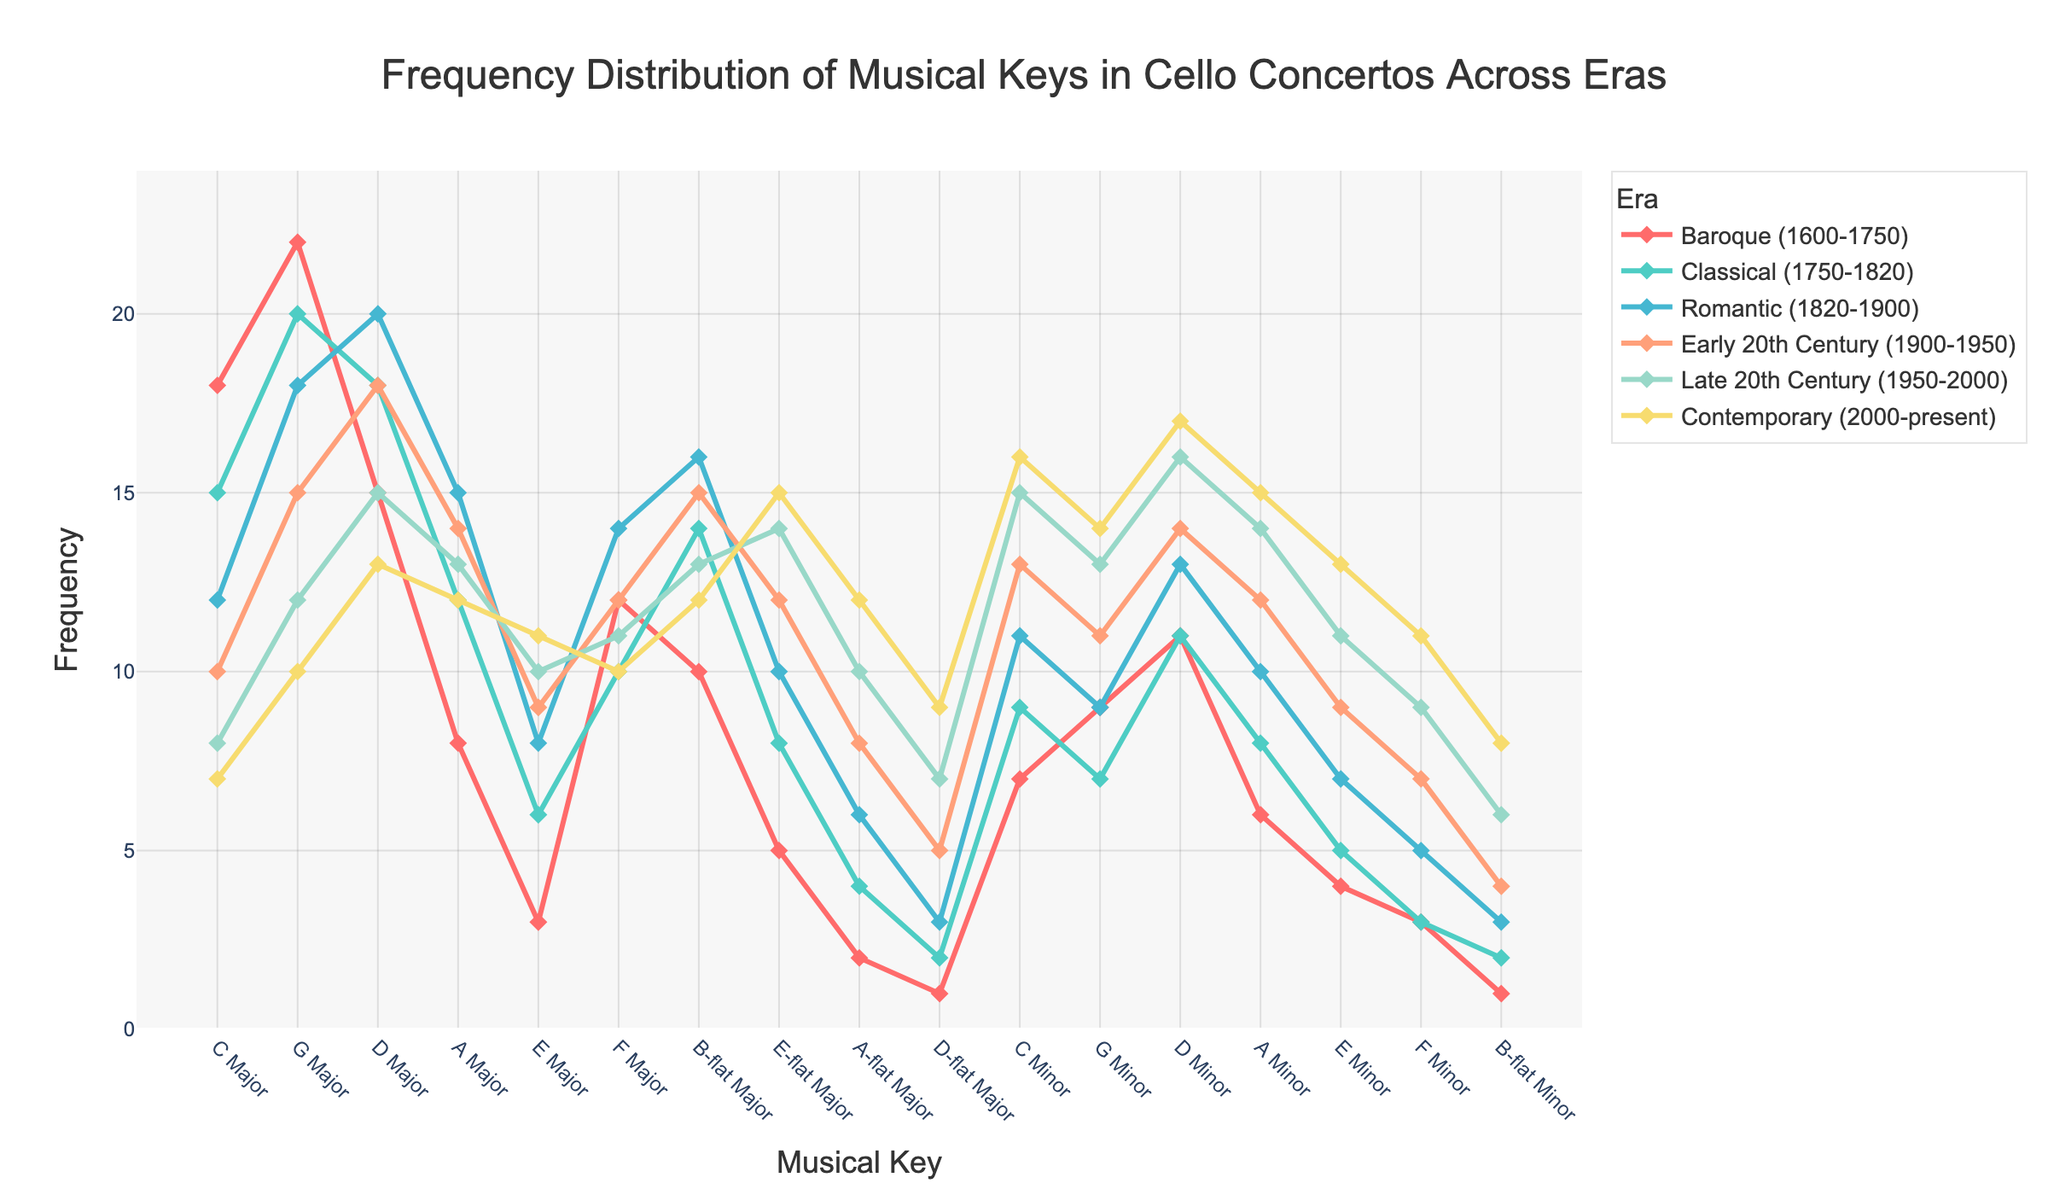Which era has the highest frequency of concertos in C Major? Look for the era with the tallest line at the point corresponding to C Major. In this case, it's the "Baroque (1600-1750)" era with a frequency of 18.
Answer: Baroque (1600-1750) How does the frequency of D Minor concertos change from the Classical to the Contemporary era? Observe the frequency of D Minor in the Classical and Contemporary eras. In the Classical era, it is 11. In the Contemporary era, it is 17. Subtract the former from the latter to find the change.
Answer: Increased by 6 Which musical key shows the most significant increase from the Baroque era to the Contemporary era? Compare the frequencies of each musical key in both eras, looking for the key with the maximum increase. D Minor goes from 11 in Baroque to 17 in Contemporary, with an increase of 6.
Answer: D Minor What's the average frequency of concertos in G Major across all eras? Sum the frequencies of G Major across all eras (22 + 20 + 18 + 15 + 12 + 10 = 97). Divide by the number of eras (6).
Answer: 16.17 Which era has the most balanced frequency distribution across all musical keys? A balanced distribution means frequencies are roughly similar. The Romantic and Early 20th Century eras show more uniform distributions across keys compared to others.
Answer: Romantic or Early 20th Century How does the popularity of A Major in the Late 20th Century compare to the Baroque era? Check the frequencies of A Major in the Late 20th Century (13) and Baroque era (8). The Late 20th Century has a higher frequency.
Answer: 5 more in Late 20th Century Which musical key has the least variation in frequency across all eras? Minimal variation can be spotted by visually inspecting the lines for flatness. F Minor has frequencies close to each other across different eras.
Answer: F Minor What is the difference in frequency of E Minor concertos between the Early 20th Century and Contemporary era? In the Early 20th Century, the frequency is 9; in the Contemporary era, it is 13. The difference is 13 - 9.
Answer: 4 Which era witnessed a decline in the number of B-flat Major concertos compared to the previous era? Observe B-flat Major frequencies and note any drop. From Early 20th Century (15) to Late 20th Century (13), there is a decline.
Answer: Late 20th Century What is the sum of frequencies for C Minor during the Romantic and Early 20th Century eras? Add the frequencies of C Minor for the Romantic (11) and Early 20th Century (13) eras.
Answer: 24 